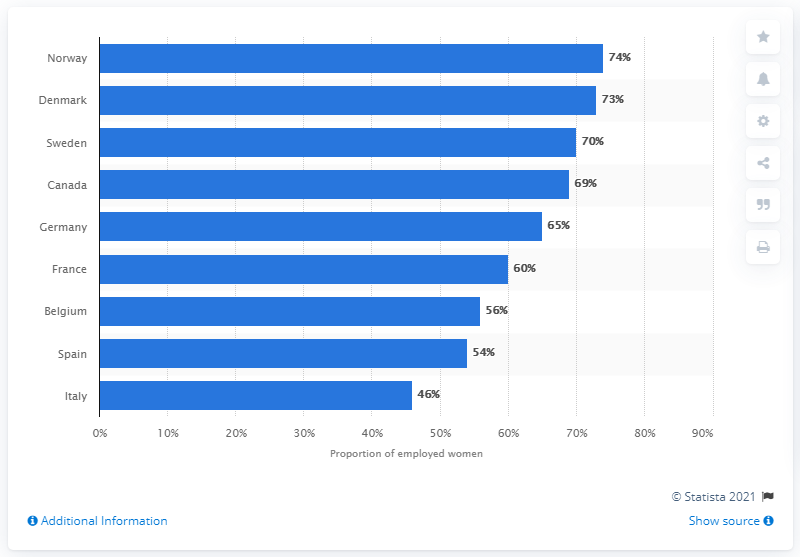Identify some key points in this picture. In 2009, 74% of women in Norway were working. 